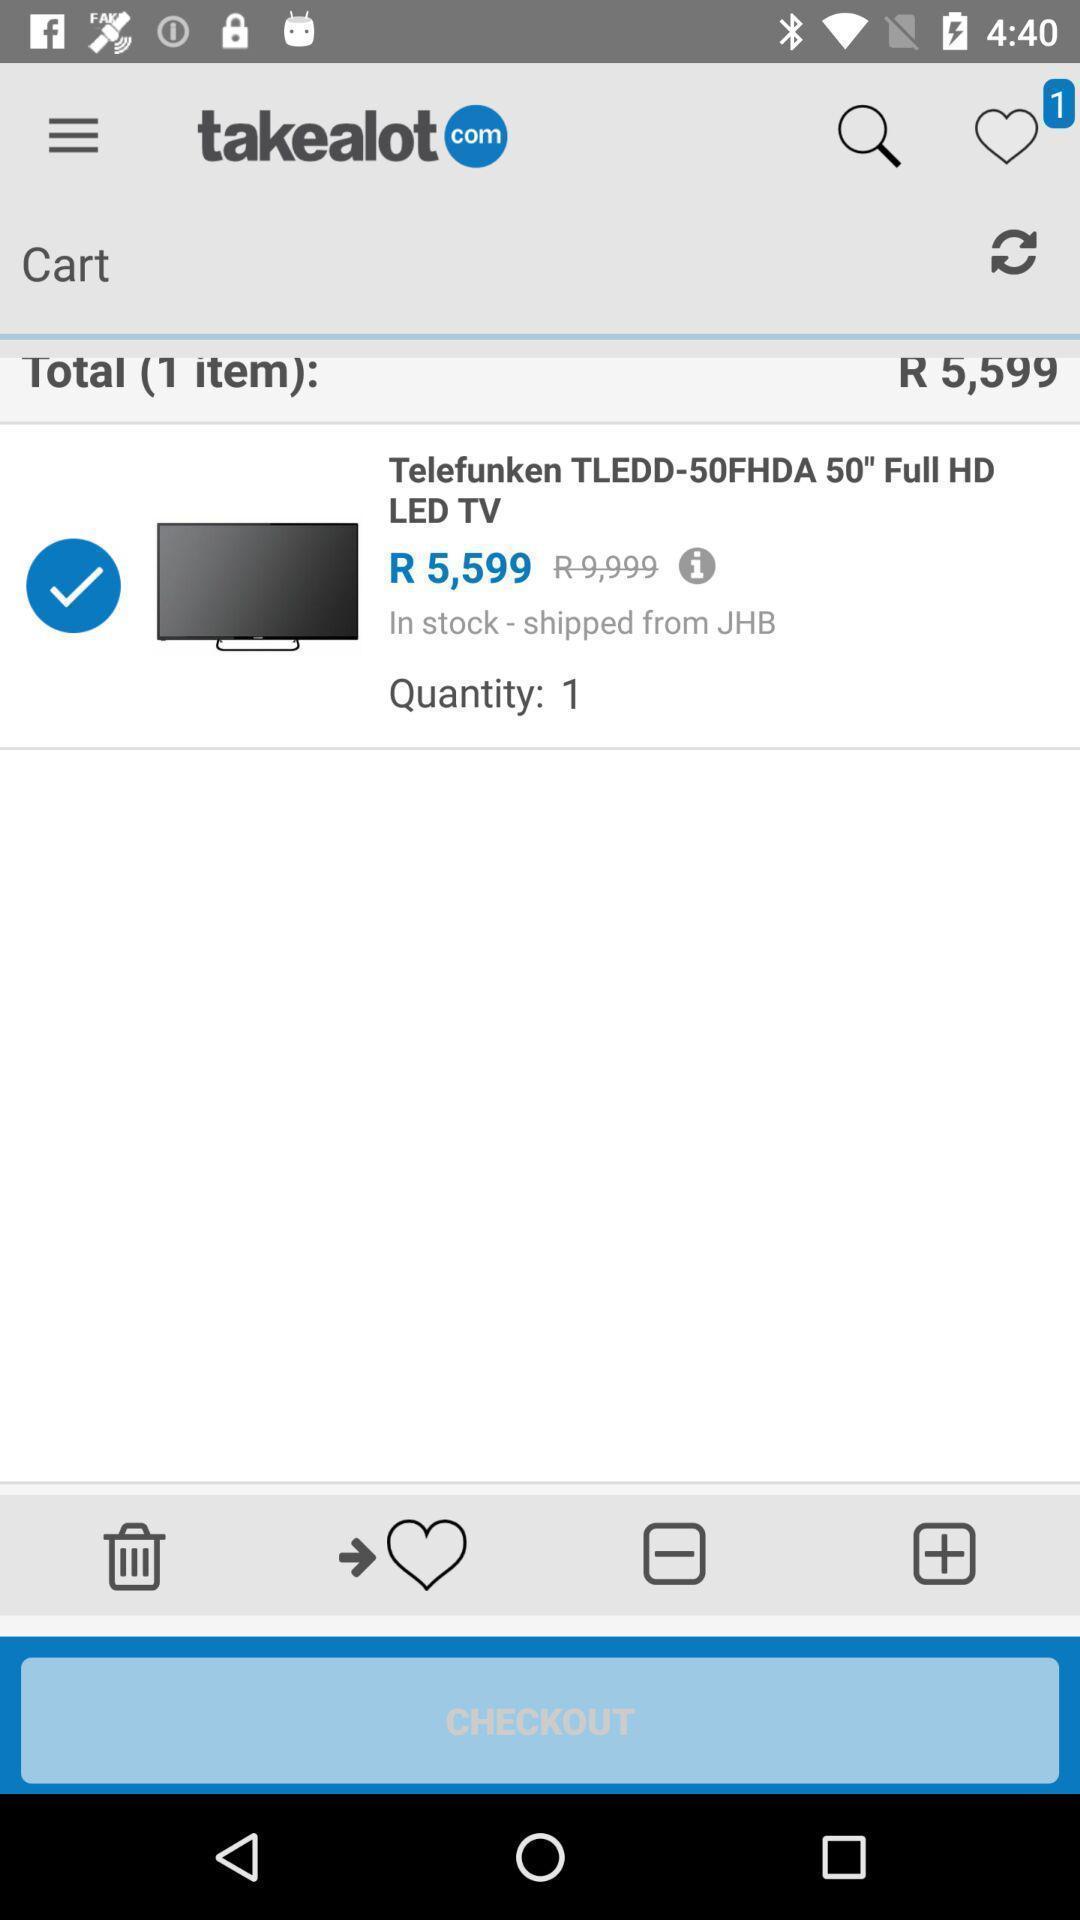Tell me what you see in this picture. Page of cart details in a shopping app. 